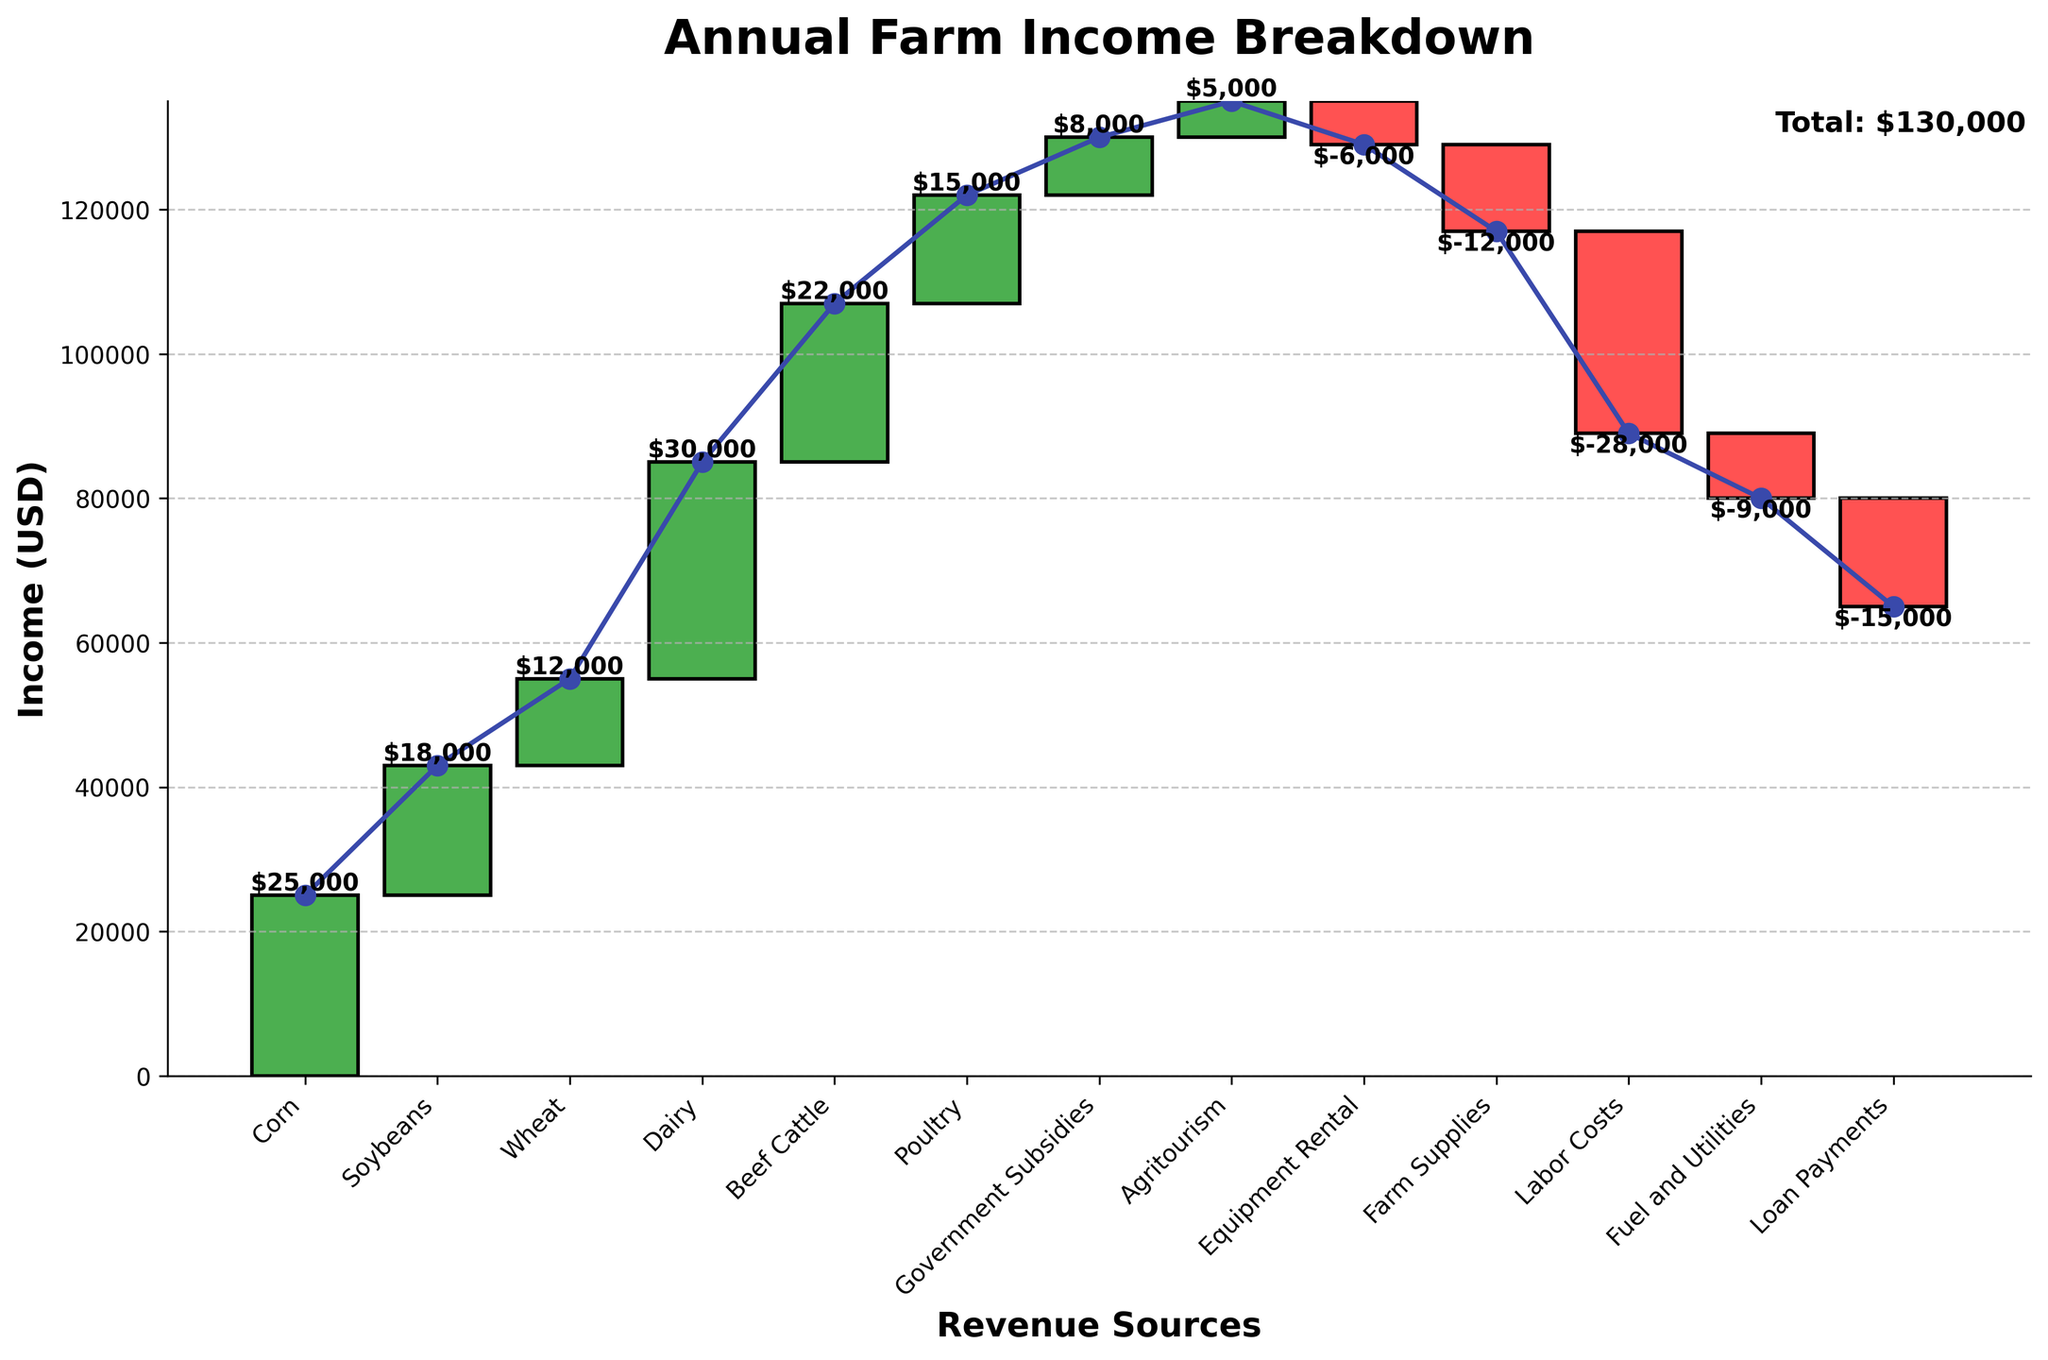what is the title of the chart? The title can be found at the top of the chart. It directly states the main purpose of the figure.
Answer: Annual Farm Income Breakdown Which revenue source contributes the most to the farm's annual income? The height of the bars indicates the contribution, where larger bars contribute more.
Answer: Dairy What is the total value of the expenses related to Equipment Rental, Farm Supplies, Labor Costs, Fuel and Utilities, and Loan Payments? Sum the negative values of these categories: -6000 (Equipment Rental) + -12000 (Farm Supplies) + -28000 (Labor Costs) + -9000 (Fuel and Utilities) + -15000 (Loan Payments) = -70000
Answer: -70000 Which revenue source contributes the least to the farm's annual income? The smallest positive bar after excluding the 'Starting Income' and 'Total Annual Income' categories indicates the least contribution.
Answer: Agritourism How much more does Corn contribute to income compared to Soybeans? Subtract the income from Soybeans from the income from Corn: 25000 - 18000 = 7000
Answer: 7000 What is the overall effect of the expenses on the farm's income? The total expenses can be found by summing all the negative values: -6000 (Equipment Rental) + -12000 (Farm Supplies) + -28000 (Labor Costs) + -9000 (Fuel and Utilities) + -15000 (Loan Payments) = -70000
Answer: -70000 Which revenue sources are grouped under livestock in the chart? Livestock-related categories can be identified by their titles, which in this case are Dairy, Beef Cattle, and Poultry.
Answer: Dairy, Beef Cattle, Poultry What is the total income before expenses are deducted? Sum all positive values from revenue sources: 25000 (Corn) + 18000 (Soybeans) + 12000 (Wheat) + 30000 (Dairy) + 22000 (Beef Cattle) + 15000 (Poultry) + 8000 (Government Subsidies) + 5000 (Agritourism) = 135,000
Answer: 135,000 How does Labor Costs affect the cumulative income in the chart? Identify the bar corresponding to Labor Costs, which reduces the cumulative income by 28000.
Answer: Reduces by 28000 Considering the total annual income, what could explain why the farm remains profitable? Despite significant deductions from various expenses, substantial earnings from multiple revenue sources, especially Dairy and Corn, plus additional support like Government Subsidies, stabilize the income.
Answer: Substantial revenue sources and subsidies 